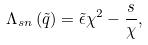<formula> <loc_0><loc_0><loc_500><loc_500>\Lambda _ { s n } \left ( \tilde { q } \right ) = \tilde { \epsilon } \chi ^ { 2 } - \frac { s } { \chi } ,</formula> 